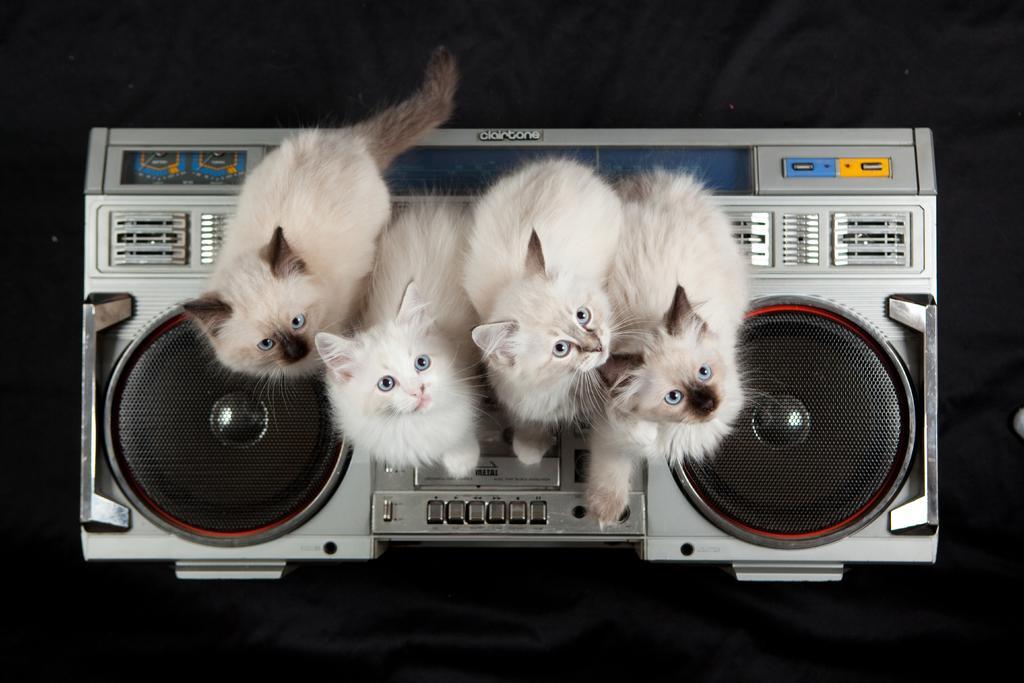Describe this image in one or two sentences. In this image we can see a few cats on an electronic gadget. Behind the gadget we can see a dark background. 